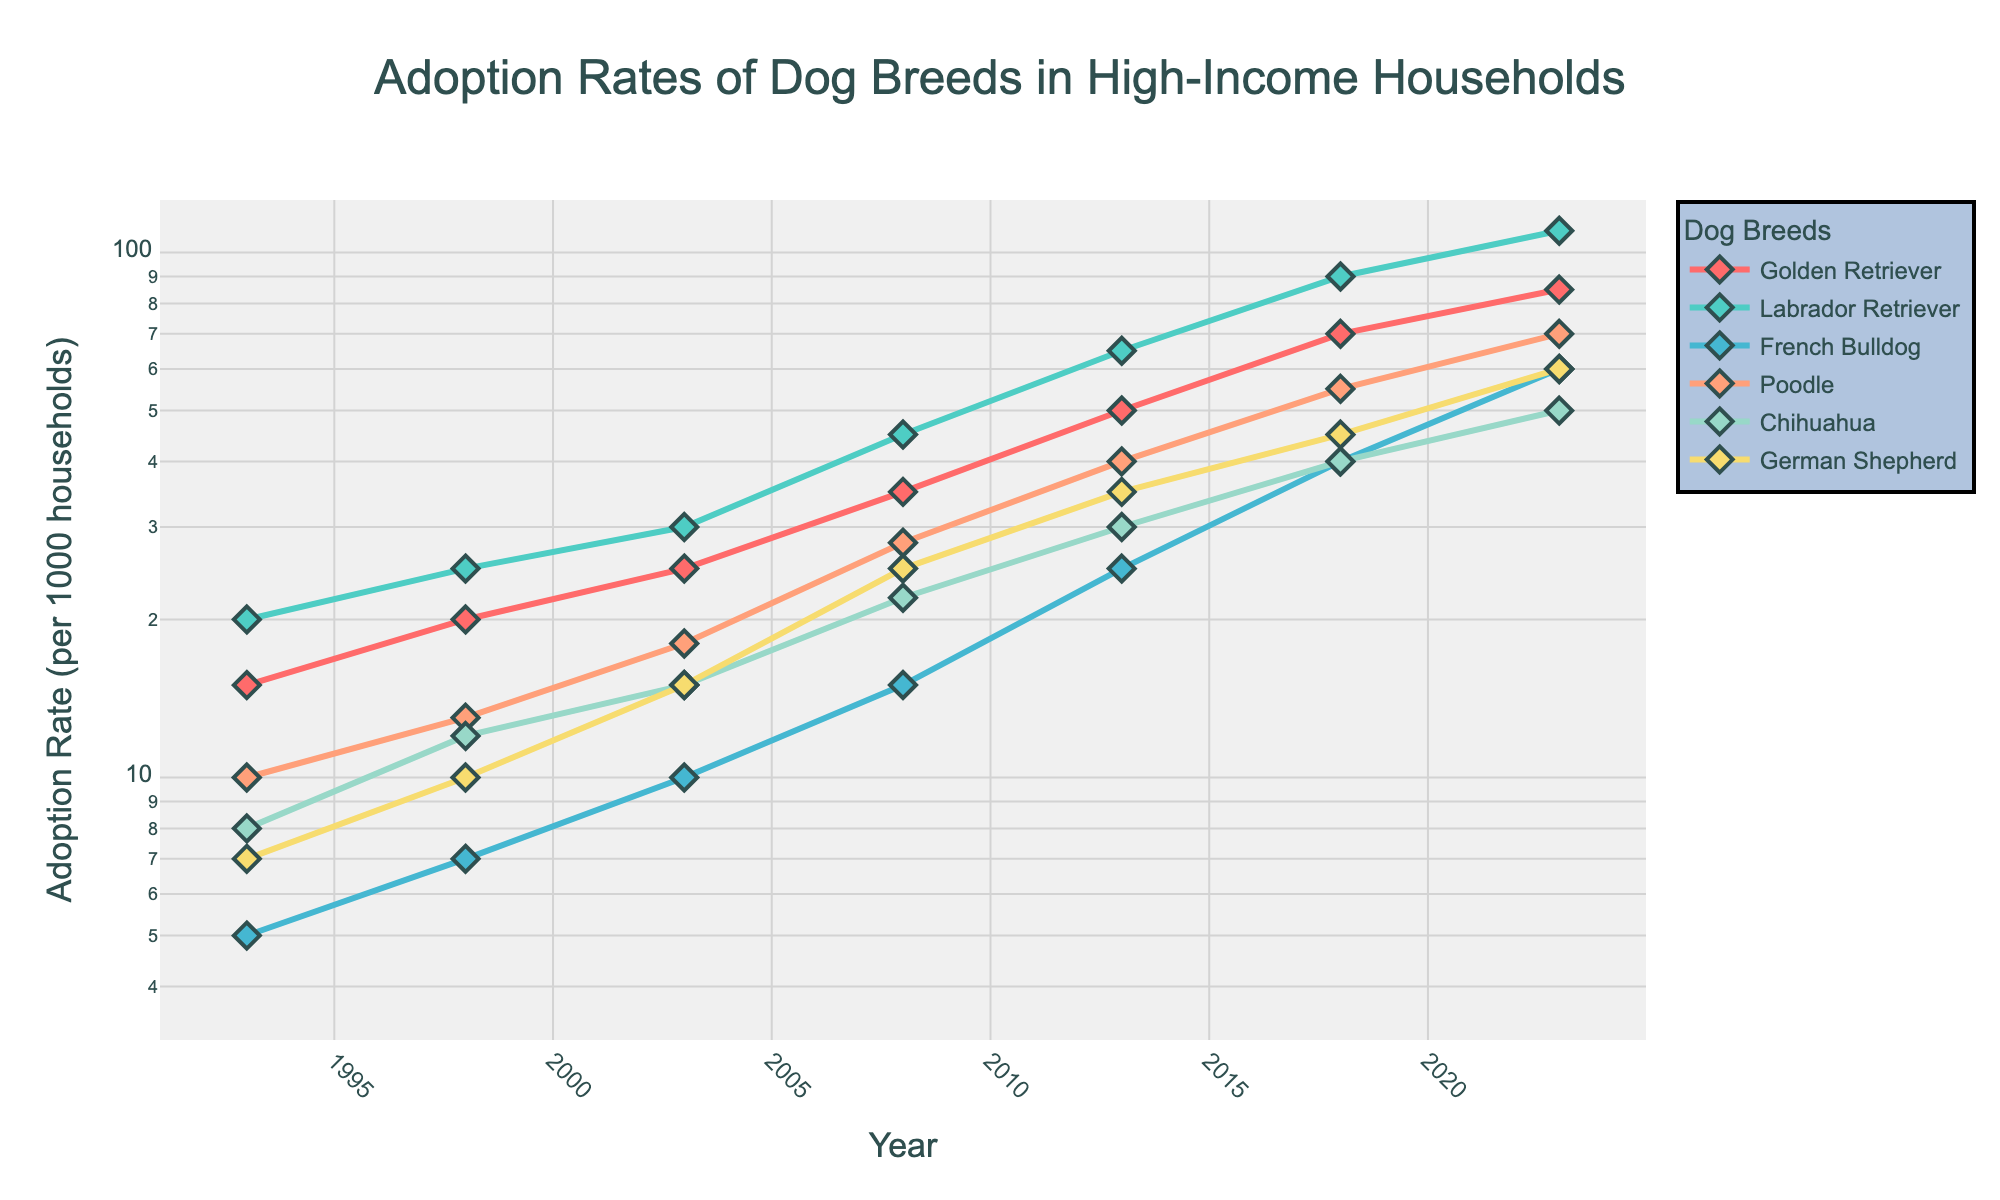What's the title of the figure? The title of the figure is located at the top center of the plot.
Answer: Adoption Rates of Dog Breeds in High-Income Households How many breeds are represented in the plot? There are different colored lines representing different breeds, with unique markers for each breed. Counting these, we have six breeds.
Answer: Six Which breed had the highest adoption rate in 2023? Look at the adoption rates for all breeds in the year 2023. The Labrador Retriever reaches the highest point on the y-axis in 2023.
Answer: Labrador Retriever How did the adoption rate of Golden Retrievers change from 1993 to 2023? Find the points for Golden Retrievers in 1993 and 2023 on the plot, and observe the change in their y-axis values. The rate increased from 15 to 85.
Answer: Increased from 15 to 85 Which breed had a higher adoption rate in 2008, French Bulldogs or German Shepherds? Compare the adoption rates for French Bulldogs and German Shepherds in the year 2008. The point for French Bulldogs is lower than that of German Shepherds.
Answer: German Shepherds What is the rate of increase in the adoption rate of Poodles from 1993 to 2023? To find the rate of increase, subtract the adoption rate in 1993 from the adoption rate in 2023 for Poodles, i.e., 70 - 10.
Answer: 60 Which breed showed the most significant percentage increase in their adoption rate from 1993 to 2023? Calculate the percentage increase for each breed using the formula: ((Adoption Rate in 2023 - Adoption Rate in 1993) / Adoption Rate in 1993) * 100. The breed with the highest percentage increase is the French Bulldog with an increase from 5 to 60.
Answer: French Bulldog What color represents the Poodle breed in the plot? In the figure, Poodles are represented by one specific color. By observing the legend, Poodles are associated with a light pink color.
Answer: Light Pink Which breed's adoption rate was closest to 50 per 1000 households in 2018? Look at the 2018 data points on the log scale y-axis to see which breed's adoption rate is nearest to 50. The Golden Retriever adoption rate is exactly 50 in 2018.
Answer: Golden Retriever Between which years did the Labrador Retrievers see the most significant increase in adoption rates? Examine the slope of the Labrador Retriever line on the plot. The sharpest increase occurred between 2013 and 2018, where the rate jumps from 65 to 90.
Answer: 2013 to 2018 